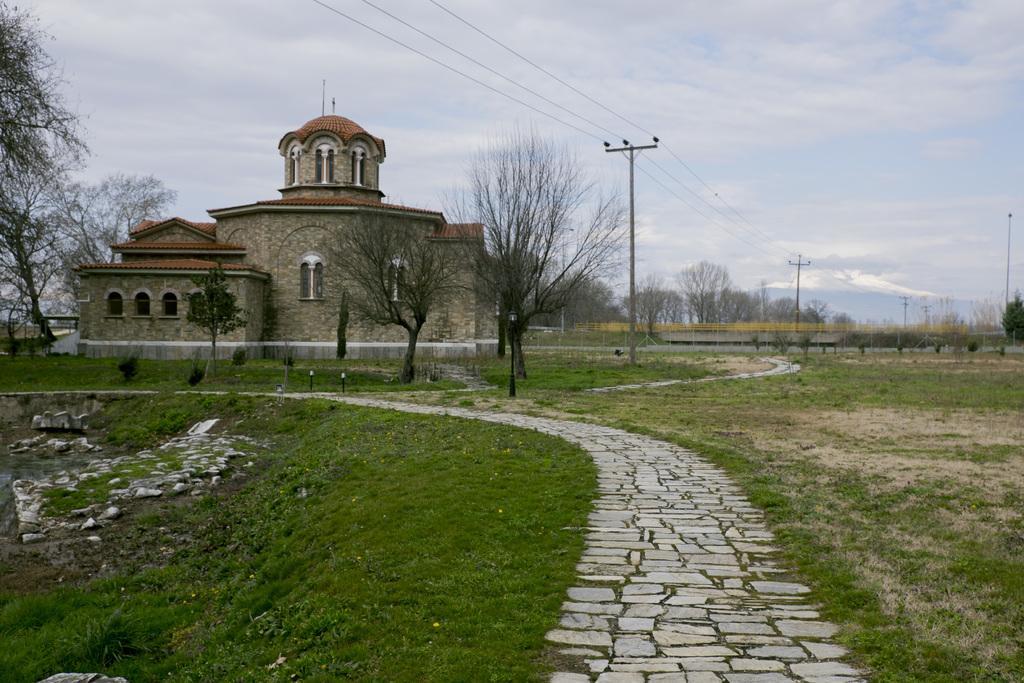Please provide a concise description of this image. In this picture, we can see building with windows, and we can see the ground with grass, path, trees, poles, wires, and the sky with clouds. 